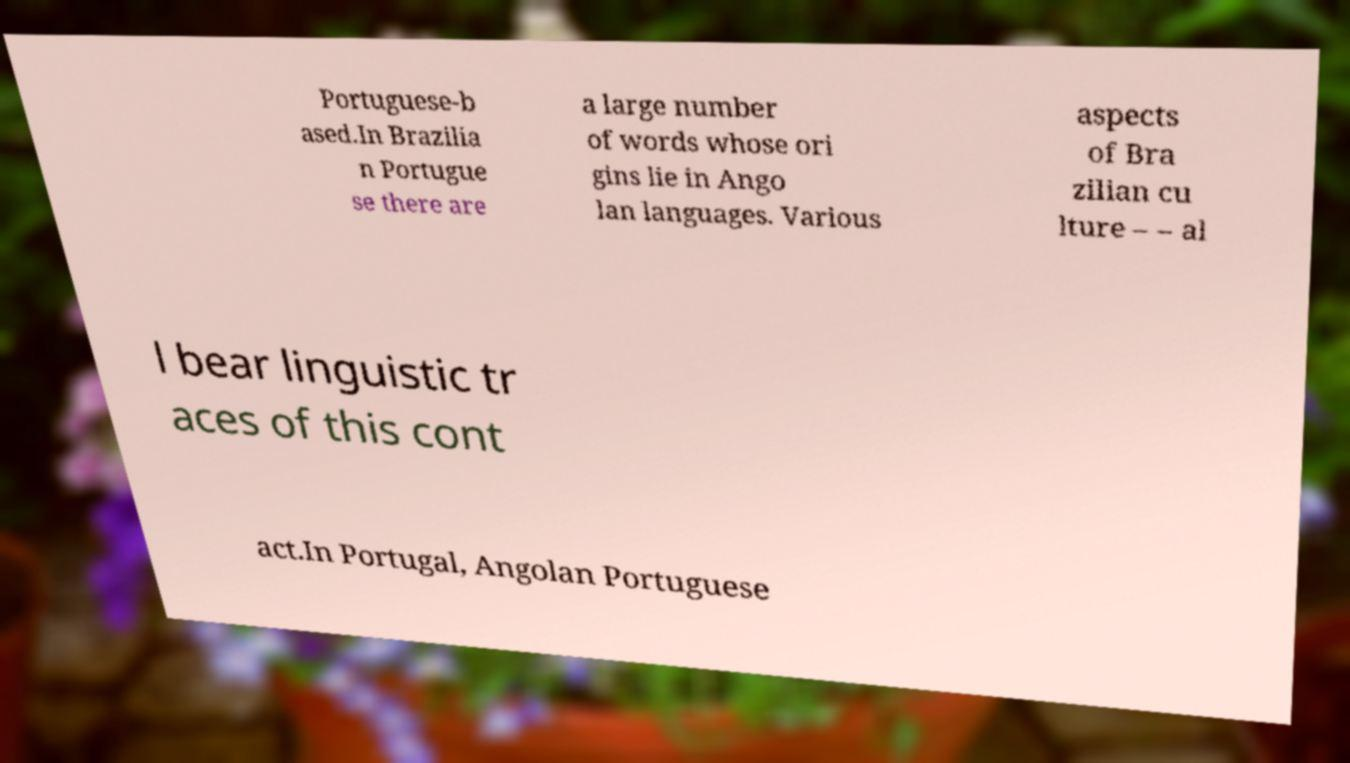For documentation purposes, I need the text within this image transcribed. Could you provide that? Portuguese-b ased.In Brazilia n Portugue se there are a large number of words whose ori gins lie in Ango lan languages. Various aspects of Bra zilian cu lture – – al l bear linguistic tr aces of this cont act.In Portugal, Angolan Portuguese 